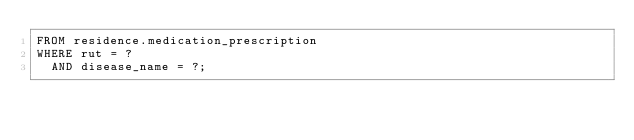Convert code to text. <code><loc_0><loc_0><loc_500><loc_500><_SQL_>FROM residence.medication_prescription
WHERE rut = ?
  AND disease_name = ?;</code> 